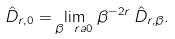Convert formula to latex. <formula><loc_0><loc_0><loc_500><loc_500>\hat { D } _ { r , 0 } = \lim _ { \beta \ r a 0 } \, \beta ^ { - 2 r } \, \hat { D } _ { r , \beta } .</formula> 